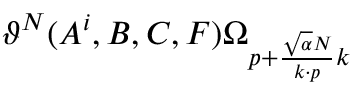<formula> <loc_0><loc_0><loc_500><loc_500>\vartheta ^ { N } ( A ^ { i } , B , C , F ) \Omega _ { p + { \frac { \sqrt { \alpha } N } { k \cdot p } } k }</formula> 